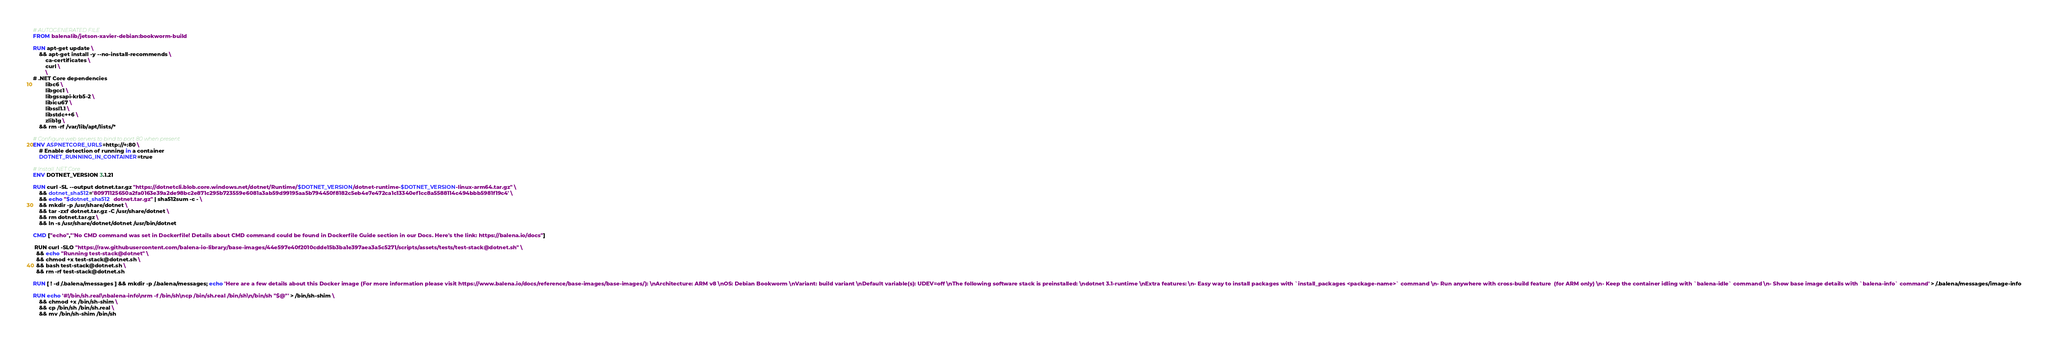Convert code to text. <code><loc_0><loc_0><loc_500><loc_500><_Dockerfile_># AUTOGENERATED FILE
FROM balenalib/jetson-xavier-debian:bookworm-build

RUN apt-get update \
    && apt-get install -y --no-install-recommends \
        ca-certificates \
        curl \
        \
# .NET Core dependencies
        libc6 \
        libgcc1 \
        libgssapi-krb5-2 \
        libicu67 \
        libssl1.1 \
        libstdc++6 \
        zlib1g \
    && rm -rf /var/lib/apt/lists/*

# Configure web servers to bind to port 80 when present
ENV ASPNETCORE_URLS=http://+:80 \
    # Enable detection of running in a container
    DOTNET_RUNNING_IN_CONTAINER=true

# Install .NET Core
ENV DOTNET_VERSION 3.1.21

RUN curl -SL --output dotnet.tar.gz "https://dotnetcli.blob.core.windows.net/dotnet/Runtime/$DOTNET_VERSION/dotnet-runtime-$DOTNET_VERSION-linux-arm64.tar.gz" \
    && dotnet_sha512='80971125650a2fa0163e39a2de98bc2e871c295b723559e6081a3ab59d99195aa5b794450f8182c5eb4e7e472ca1c13340ef1cc8a5588114c494bbb5981f19c4' \
    && echo "$dotnet_sha512  dotnet.tar.gz" | sha512sum -c - \
    && mkdir -p /usr/share/dotnet \
    && tar -zxf dotnet.tar.gz -C /usr/share/dotnet \
    && rm dotnet.tar.gz \
    && ln -s /usr/share/dotnet/dotnet /usr/bin/dotnet

CMD ["echo","'No CMD command was set in Dockerfile! Details about CMD command could be found in Dockerfile Guide section in our Docs. Here's the link: https://balena.io/docs"]

 RUN curl -SLO "https://raw.githubusercontent.com/balena-io-library/base-images/44e597e40f2010cdde15b3ba1e397aea3a5c5271/scripts/assets/tests/test-stack@dotnet.sh" \
  && echo "Running test-stack@dotnet" \
  && chmod +x test-stack@dotnet.sh \
  && bash test-stack@dotnet.sh \
  && rm -rf test-stack@dotnet.sh 

RUN [ ! -d /.balena/messages ] && mkdir -p /.balena/messages; echo 'Here are a few details about this Docker image (For more information please visit https://www.balena.io/docs/reference/base-images/base-images/): \nArchitecture: ARM v8 \nOS: Debian Bookworm \nVariant: build variant \nDefault variable(s): UDEV=off \nThe following software stack is preinstalled: \ndotnet 3.1-runtime \nExtra features: \n- Easy way to install packages with `install_packages <package-name>` command \n- Run anywhere with cross-build feature  (for ARM only) \n- Keep the container idling with `balena-idle` command \n- Show base image details with `balena-info` command' > /.balena/messages/image-info

RUN echo '#!/bin/sh.real\nbalena-info\nrm -f /bin/sh\ncp /bin/sh.real /bin/sh\n/bin/sh "$@"' > /bin/sh-shim \
	&& chmod +x /bin/sh-shim \
	&& cp /bin/sh /bin/sh.real \
	&& mv /bin/sh-shim /bin/sh</code> 